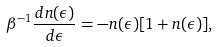Convert formula to latex. <formula><loc_0><loc_0><loc_500><loc_500>\beta ^ { - 1 } \frac { d n ( \epsilon ) } { d \epsilon } = - n ( \epsilon ) [ 1 + n ( \epsilon ) ] ,</formula> 